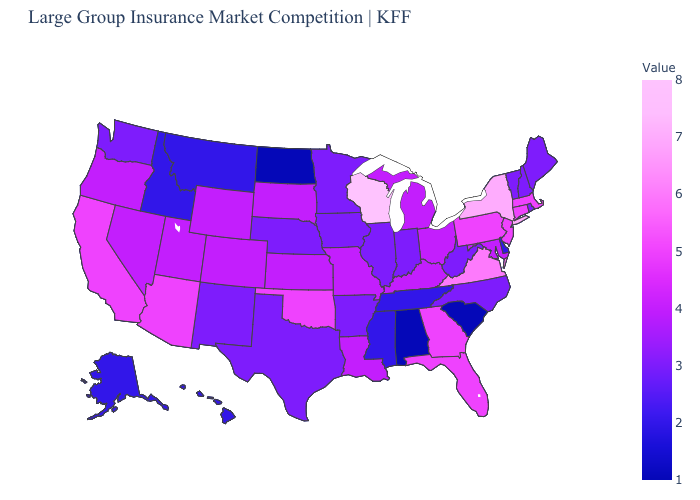Which states have the lowest value in the USA?
Be succinct. Alabama, North Dakota, South Carolina. Is the legend a continuous bar?
Short answer required. Yes. Which states have the lowest value in the South?
Be succinct. Alabama, South Carolina. Which states hav the highest value in the West?
Be succinct. Arizona, California. Among the states that border Nebraska , does Iowa have the highest value?
Quick response, please. No. 